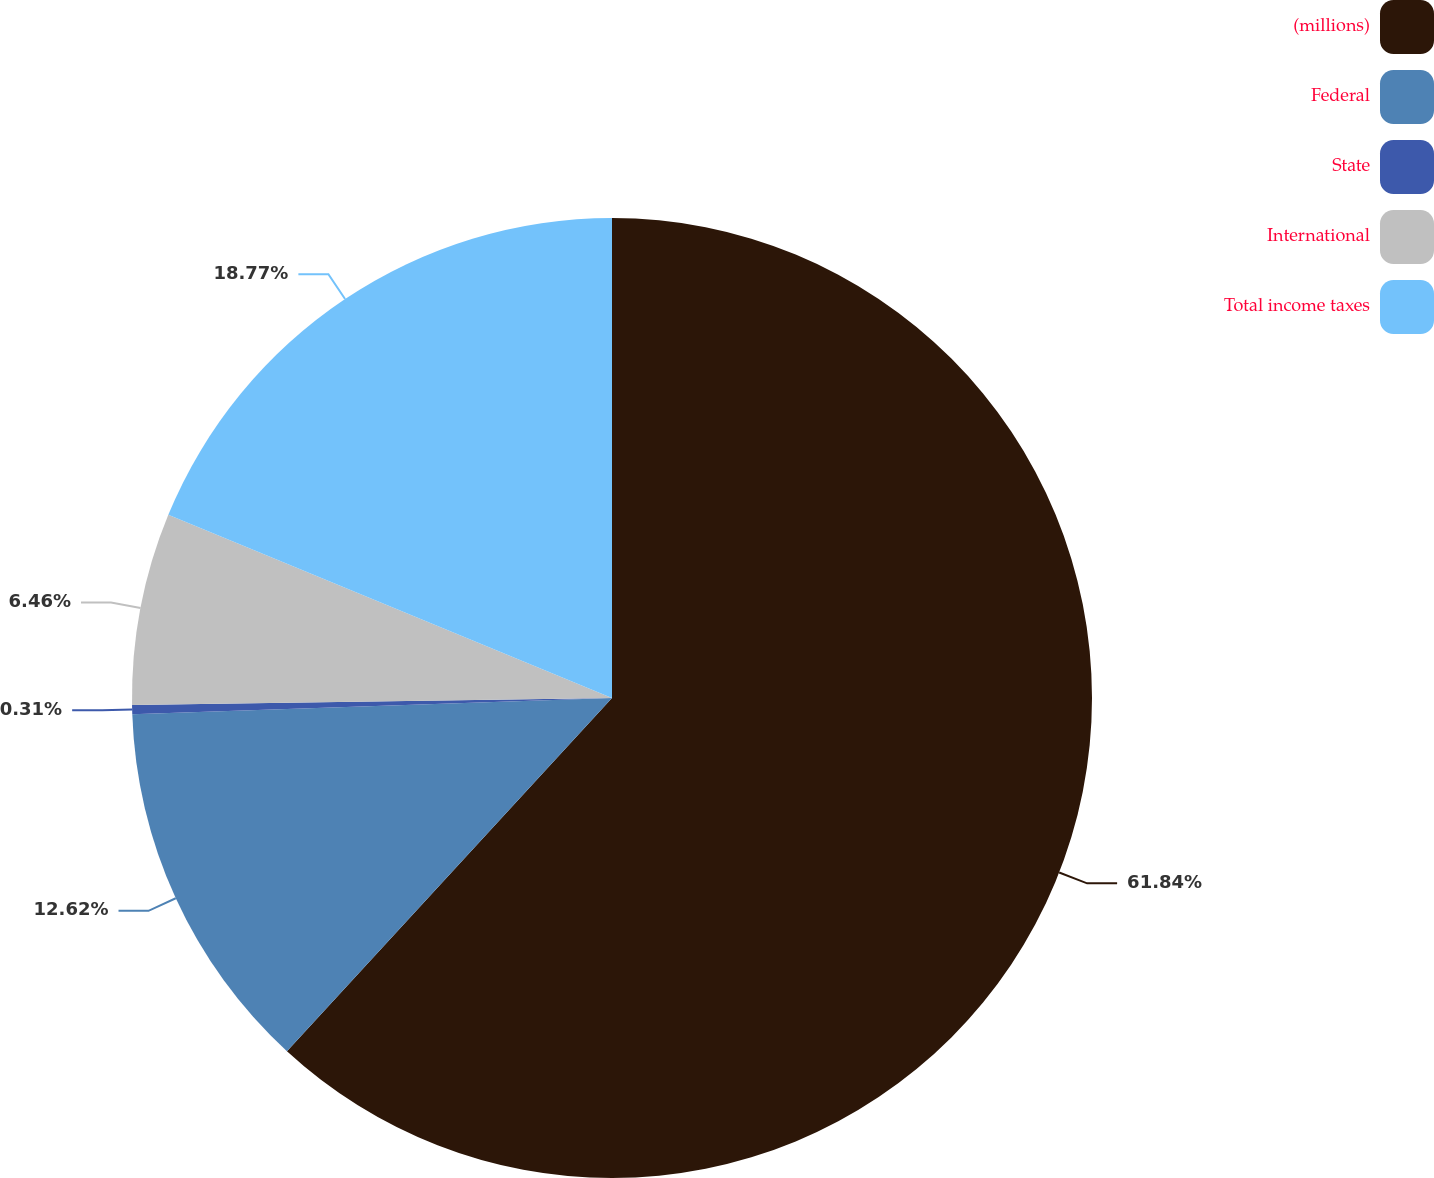Convert chart. <chart><loc_0><loc_0><loc_500><loc_500><pie_chart><fcel>(millions)<fcel>Federal<fcel>State<fcel>International<fcel>Total income taxes<nl><fcel>61.84%<fcel>12.62%<fcel>0.31%<fcel>6.46%<fcel>18.77%<nl></chart> 